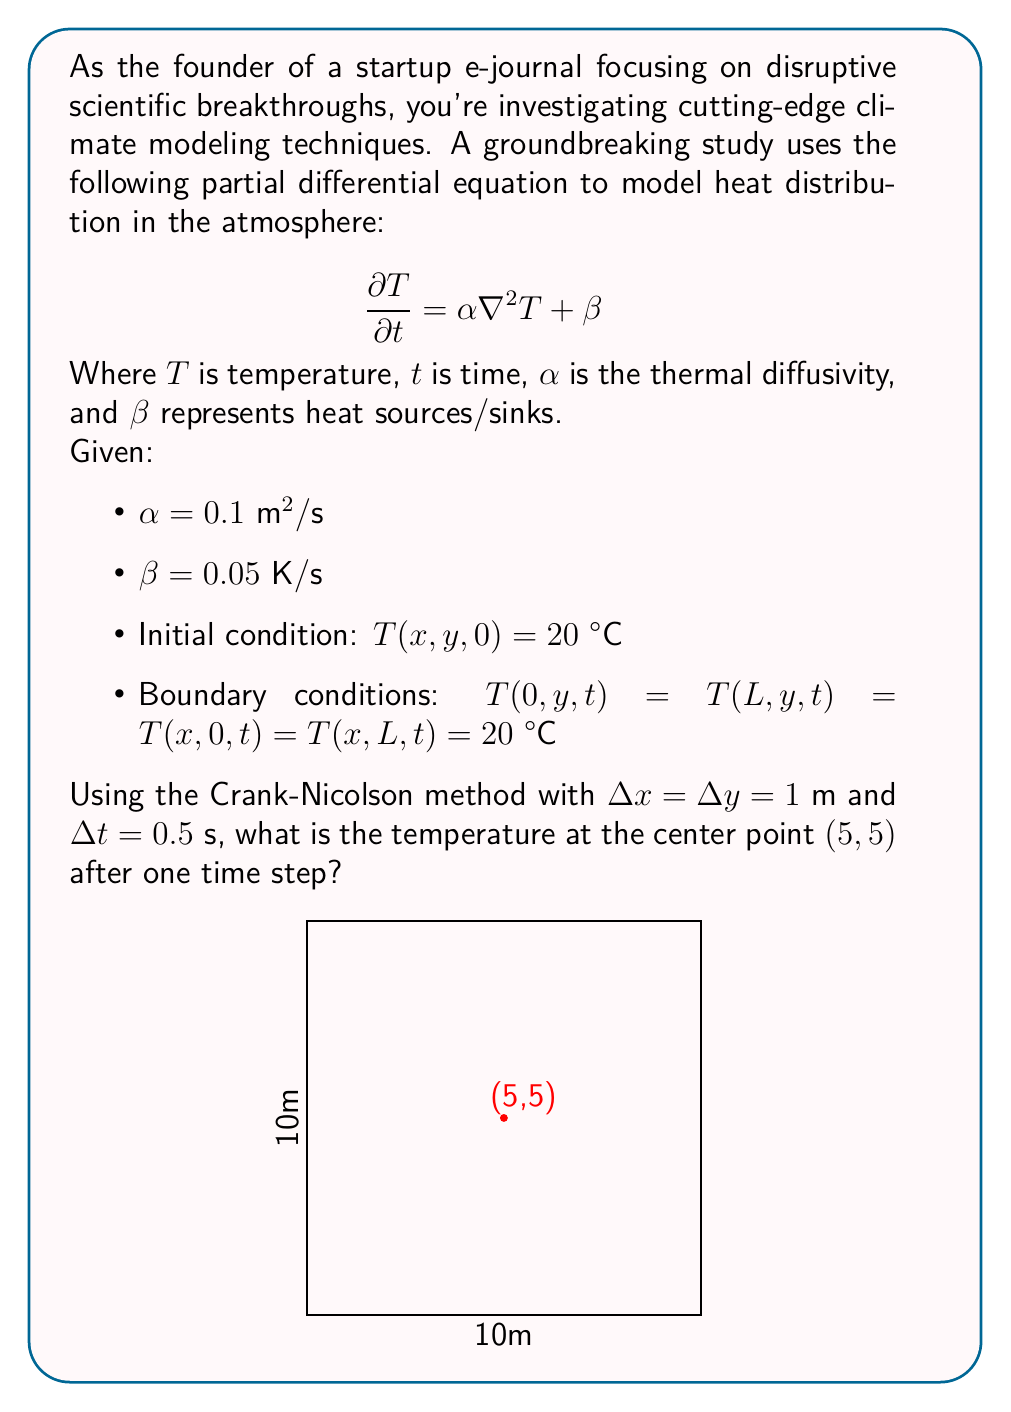Solve this math problem. To solve this problem, we'll use the Crank-Nicolson method for the 2D heat equation. The steps are as follows:

1) The Crank-Nicolson scheme for this PDE is:

   $$\frac{T_{i,j}^{n+1} - T_{i,j}^n}{\Delta t} = \frac{\alpha}{2} [\nabla^2 T_{i,j}^{n+1} + \nabla^2 T_{i,j}^n] + \beta$$

2) Expand the Laplacian terms:

   $$\frac{T_{i,j}^{n+1} - T_{i,j}^n}{\Delta t} = \frac{\alpha}{2} [\frac{T_{i+1,j}^{n+1} + T_{i-1,j}^{n+1} + T_{i,j+1}^{n+1} + T_{i,j-1}^{n+1} - 4T_{i,j}^{n+1}}{(\Delta x)^2} + \frac{T_{i+1,j}^n + T_{i-1,j}^n + T_{i,j+1}^n + T_{i,j-1}^n - 4T_{i,j}^n}{(\Delta x)^2}] + \beta$$

3) Rearrange the equation:

   $$T_{i,j}^{n+1} - \frac{\alpha \Delta t}{2(\Delta x)^2}(T_{i+1,j}^{n+1} + T_{i-1,j}^{n+1} + T_{i,j+1}^{n+1} + T_{i,j-1}^{n+1} - 4T_{i,j}^{n+1}) = T_{i,j}^n + \frac{\alpha \Delta t}{2(\Delta x)^2}(T_{i+1,j}^n + T_{i-1,j}^n + T_{i,j+1}^n + T_{i,j-1}^n - 4T_{i,j}^n) + \beta \Delta t$$

4) Define $r = \frac{\alpha \Delta t}{2(\Delta x)^2}$. With the given values, $r = \frac{0.1 \cdot 0.5}{2 \cdot 1^2} = 0.025$

5) For the center point (5,5), all neighboring points are at 20°C initially. Substituting the values:

   $$(1+4r)T_{5,5}^1 - r(T_{6,5}^1 + T_{4,5}^1 + T_{5,6}^1 + T_{5,4}^1) = (1-4r)20 + r(20 + 20 + 20 + 20) + 0.05 \cdot 0.5$$

6) Simplify:

   $$1.1T_{5,5}^1 - 0.025(T_{6,5}^1 + T_{4,5}^1 + T_{5,6}^1 + T_{5,4}^1) = 20 + 0.025$$

7) Due to symmetry, we can assume $T_{6,5}^1 = T_{4,5}^1 = T_{5,6}^1 = T_{5,4}^1 = T_{5,5}^1$. Substituting:

   $$1.1T_{5,5}^1 - 0.1T_{5,5}^1 = 20.025$$

8) Solve for $T_{5,5}^1$:

   $$T_{5,5}^1 = \frac{20.025}{1} = 20.025 \text{ °C}$$
Answer: 20.025 °C 